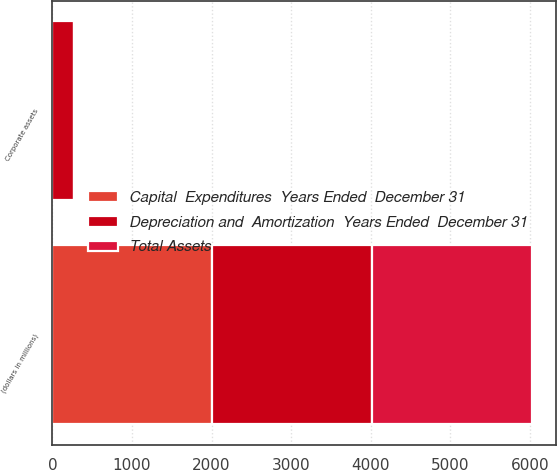<chart> <loc_0><loc_0><loc_500><loc_500><stacked_bar_chart><ecel><fcel>(dollars in millions)<fcel>Corporate assets<nl><fcel>Depreciation and  Amortization  Years Ended  December 31<fcel>2010<fcel>271<nl><fcel>Capital  Expenditures  Years Ended  December 31<fcel>2010<fcel>0.6<nl><fcel>Total Assets<fcel>2010<fcel>1.9<nl></chart> 